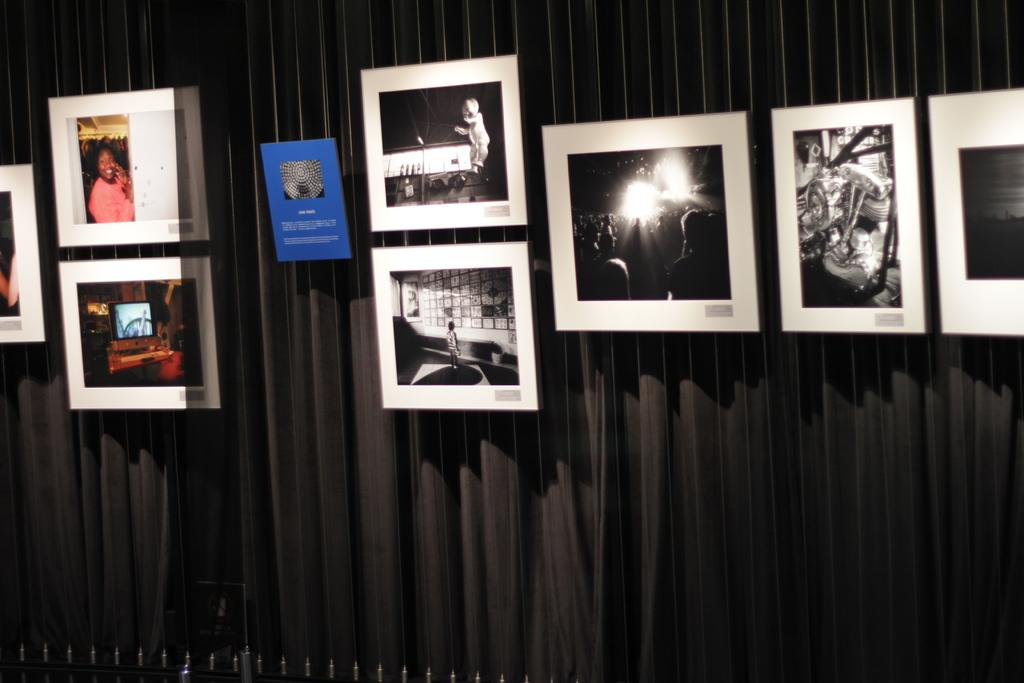What can be seen in the image that resembles a border or boundary? There are frames in the image. What is present in the background of the image? There is a curtain in the background of the image. What is located at the bottom of the image? There is a fence at the bottom of the image. What type of flesh can be seen on the ground in the image? There is no flesh or ground present in the image; it features frames, a curtain, and a fence. 